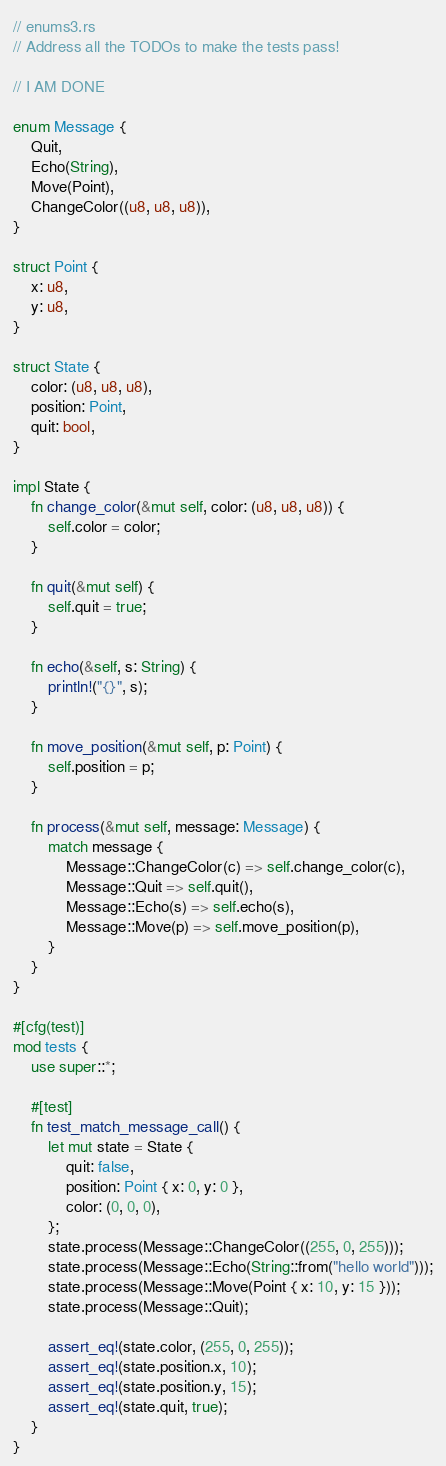Convert code to text. <code><loc_0><loc_0><loc_500><loc_500><_Rust_>// enums3.rs
// Address all the TODOs to make the tests pass!

// I AM DONE

enum Message {
    Quit,
    Echo(String),
    Move(Point),
    ChangeColor((u8, u8, u8)),
}

struct Point {
    x: u8,
    y: u8,
}

struct State {
    color: (u8, u8, u8),
    position: Point,
    quit: bool,
}

impl State {
    fn change_color(&mut self, color: (u8, u8, u8)) {
        self.color = color;
    }

    fn quit(&mut self) {
        self.quit = true;
    }

    fn echo(&self, s: String) {
        println!("{}", s);
    }

    fn move_position(&mut self, p: Point) {
        self.position = p;
    }

    fn process(&mut self, message: Message) {
        match message {
            Message::ChangeColor(c) => self.change_color(c),
            Message::Quit => self.quit(),
            Message::Echo(s) => self.echo(s),
            Message::Move(p) => self.move_position(p),
        }
    }
}

#[cfg(test)]
mod tests {
    use super::*;

    #[test]
    fn test_match_message_call() {
        let mut state = State {
            quit: false,
            position: Point { x: 0, y: 0 },
            color: (0, 0, 0),
        };
        state.process(Message::ChangeColor((255, 0, 255)));
        state.process(Message::Echo(String::from("hello world")));
        state.process(Message::Move(Point { x: 10, y: 15 }));
        state.process(Message::Quit);

        assert_eq!(state.color, (255, 0, 255));
        assert_eq!(state.position.x, 10);
        assert_eq!(state.position.y, 15);
        assert_eq!(state.quit, true);
    }
}
</code> 